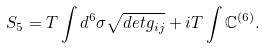Convert formula to latex. <formula><loc_0><loc_0><loc_500><loc_500>S _ { 5 } = T \int d ^ { 6 } \sigma \sqrt { d e t g _ { i j } } + i T \int { \mathbb { C } } ^ { ( 6 ) } .</formula> 